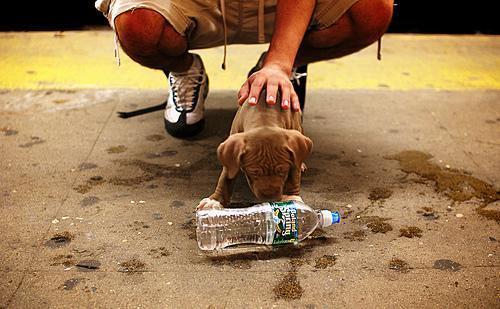How many water bottles are standing upright in the image?
Give a very brief answer. 0. 